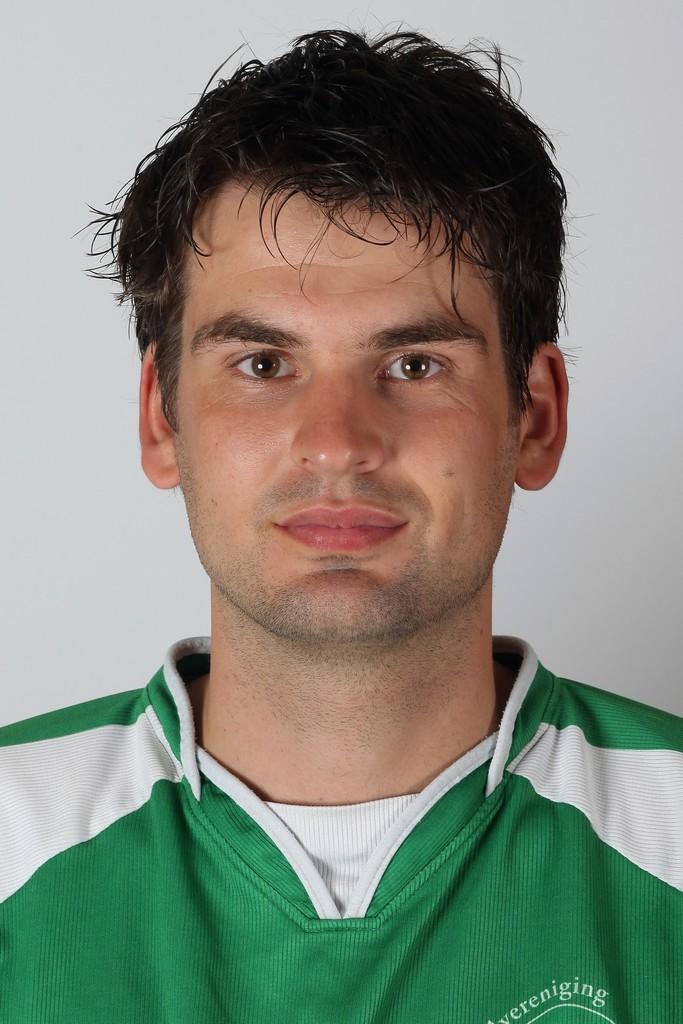Could you give a brief overview of what you see in this image? In this image we can see a man and in the background we can see the wall. 